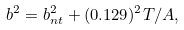<formula> <loc_0><loc_0><loc_500><loc_500>b ^ { 2 } = b _ { n t } ^ { 2 } + ( 0 . 1 2 9 ) ^ { 2 } T / A ,</formula> 